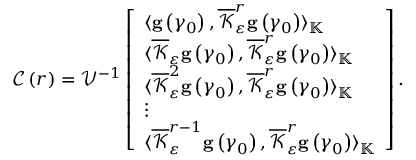Convert formula to latex. <formula><loc_0><loc_0><loc_500><loc_500>\begin{array} { r } { \mathcal { C } \left ( r \right ) = \mathcal { V } ^ { - 1 } \left [ \begin{array} { l } { \langle g \left ( \gamma _ { 0 } \right ) , \overline { { \mathcal { K } } } _ { \varepsilon } ^ { r } g \left ( \gamma _ { 0 } \right ) \rangle _ { \mathbb { K } } } \\ { \langle \overline { { \mathcal { K } } } _ { \varepsilon } g \left ( \gamma _ { 0 } \right ) , \overline { { \mathcal { K } } } _ { \varepsilon } ^ { r } g \left ( \gamma _ { 0 } \right ) \rangle _ { \mathbb { K } } } \\ { \langle \overline { { \mathcal { K } } } _ { \varepsilon } ^ { 2 } g \left ( \gamma _ { 0 } \right ) , \overline { { \mathcal { K } } } _ { \varepsilon } ^ { r } g \left ( \gamma _ { 0 } \right ) \rangle _ { \mathbb { K } } } \\ { \vdots } \\ { \langle \overline { { \mathcal { K } } } _ { \varepsilon } ^ { r - 1 } g \left ( \gamma _ { 0 } \right ) , \overline { { \mathcal { K } } } _ { \varepsilon } ^ { r } g \left ( \gamma _ { 0 } \right ) \rangle _ { \mathbb { K } } } \end{array} \right ] . } \end{array}</formula> 